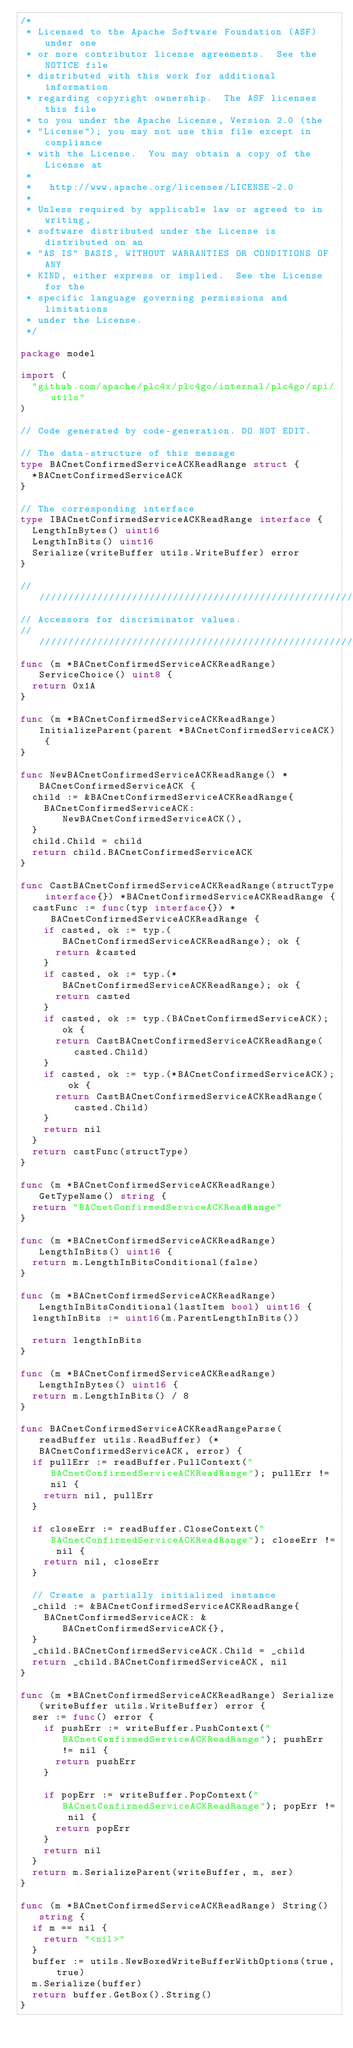<code> <loc_0><loc_0><loc_500><loc_500><_Go_>/*
 * Licensed to the Apache Software Foundation (ASF) under one
 * or more contributor license agreements.  See the NOTICE file
 * distributed with this work for additional information
 * regarding copyright ownership.  The ASF licenses this file
 * to you under the Apache License, Version 2.0 (the
 * "License"); you may not use this file except in compliance
 * with the License.  You may obtain a copy of the License at
 *
 *   http://www.apache.org/licenses/LICENSE-2.0
 *
 * Unless required by applicable law or agreed to in writing,
 * software distributed under the License is distributed on an
 * "AS IS" BASIS, WITHOUT WARRANTIES OR CONDITIONS OF ANY
 * KIND, either express or implied.  See the License for the
 * specific language governing permissions and limitations
 * under the License.
 */

package model

import (
	"github.com/apache/plc4x/plc4go/internal/plc4go/spi/utils"
)

// Code generated by code-generation. DO NOT EDIT.

// The data-structure of this message
type BACnetConfirmedServiceACKReadRange struct {
	*BACnetConfirmedServiceACK
}

// The corresponding interface
type IBACnetConfirmedServiceACKReadRange interface {
	LengthInBytes() uint16
	LengthInBits() uint16
	Serialize(writeBuffer utils.WriteBuffer) error
}

///////////////////////////////////////////////////////////
// Accessors for discriminator values.
///////////////////////////////////////////////////////////
func (m *BACnetConfirmedServiceACKReadRange) ServiceChoice() uint8 {
	return 0x1A
}

func (m *BACnetConfirmedServiceACKReadRange) InitializeParent(parent *BACnetConfirmedServiceACK) {
}

func NewBACnetConfirmedServiceACKReadRange() *BACnetConfirmedServiceACK {
	child := &BACnetConfirmedServiceACKReadRange{
		BACnetConfirmedServiceACK: NewBACnetConfirmedServiceACK(),
	}
	child.Child = child
	return child.BACnetConfirmedServiceACK
}

func CastBACnetConfirmedServiceACKReadRange(structType interface{}) *BACnetConfirmedServiceACKReadRange {
	castFunc := func(typ interface{}) *BACnetConfirmedServiceACKReadRange {
		if casted, ok := typ.(BACnetConfirmedServiceACKReadRange); ok {
			return &casted
		}
		if casted, ok := typ.(*BACnetConfirmedServiceACKReadRange); ok {
			return casted
		}
		if casted, ok := typ.(BACnetConfirmedServiceACK); ok {
			return CastBACnetConfirmedServiceACKReadRange(casted.Child)
		}
		if casted, ok := typ.(*BACnetConfirmedServiceACK); ok {
			return CastBACnetConfirmedServiceACKReadRange(casted.Child)
		}
		return nil
	}
	return castFunc(structType)
}

func (m *BACnetConfirmedServiceACKReadRange) GetTypeName() string {
	return "BACnetConfirmedServiceACKReadRange"
}

func (m *BACnetConfirmedServiceACKReadRange) LengthInBits() uint16 {
	return m.LengthInBitsConditional(false)
}

func (m *BACnetConfirmedServiceACKReadRange) LengthInBitsConditional(lastItem bool) uint16 {
	lengthInBits := uint16(m.ParentLengthInBits())

	return lengthInBits
}

func (m *BACnetConfirmedServiceACKReadRange) LengthInBytes() uint16 {
	return m.LengthInBits() / 8
}

func BACnetConfirmedServiceACKReadRangeParse(readBuffer utils.ReadBuffer) (*BACnetConfirmedServiceACK, error) {
	if pullErr := readBuffer.PullContext("BACnetConfirmedServiceACKReadRange"); pullErr != nil {
		return nil, pullErr
	}

	if closeErr := readBuffer.CloseContext("BACnetConfirmedServiceACKReadRange"); closeErr != nil {
		return nil, closeErr
	}

	// Create a partially initialized instance
	_child := &BACnetConfirmedServiceACKReadRange{
		BACnetConfirmedServiceACK: &BACnetConfirmedServiceACK{},
	}
	_child.BACnetConfirmedServiceACK.Child = _child
	return _child.BACnetConfirmedServiceACK, nil
}

func (m *BACnetConfirmedServiceACKReadRange) Serialize(writeBuffer utils.WriteBuffer) error {
	ser := func() error {
		if pushErr := writeBuffer.PushContext("BACnetConfirmedServiceACKReadRange"); pushErr != nil {
			return pushErr
		}

		if popErr := writeBuffer.PopContext("BACnetConfirmedServiceACKReadRange"); popErr != nil {
			return popErr
		}
		return nil
	}
	return m.SerializeParent(writeBuffer, m, ser)
}

func (m *BACnetConfirmedServiceACKReadRange) String() string {
	if m == nil {
		return "<nil>"
	}
	buffer := utils.NewBoxedWriteBufferWithOptions(true, true)
	m.Serialize(buffer)
	return buffer.GetBox().String()
}
</code> 